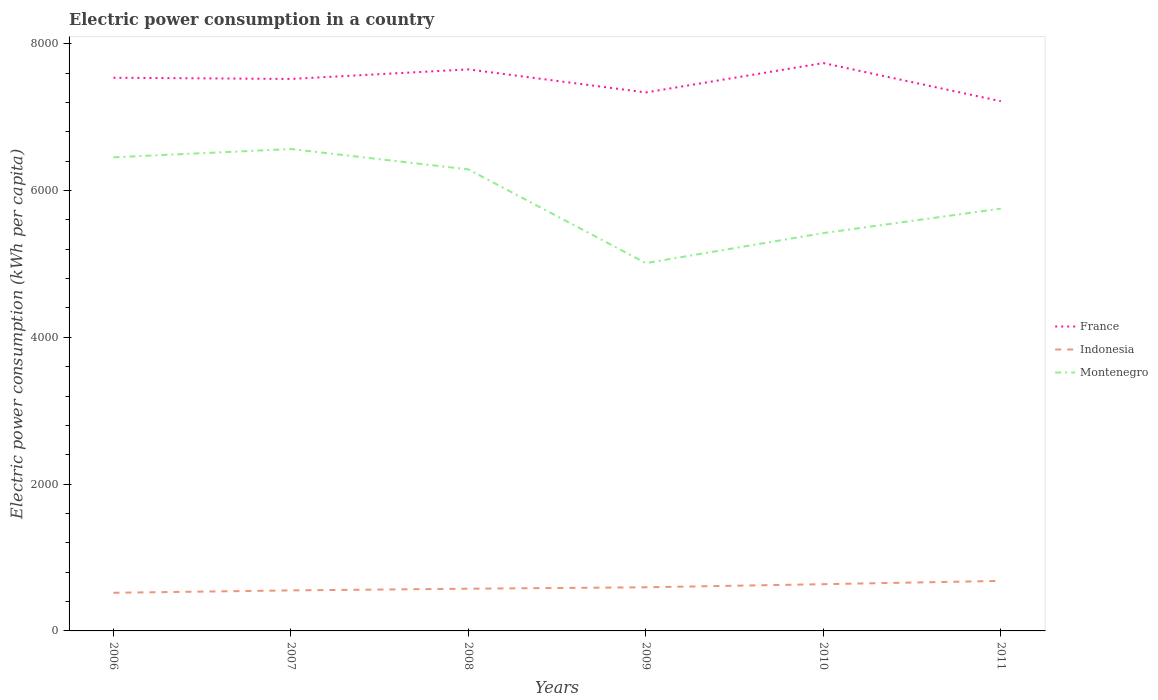How many different coloured lines are there?
Ensure brevity in your answer.  3. Does the line corresponding to Montenegro intersect with the line corresponding to Indonesia?
Your answer should be compact. No. Is the number of lines equal to the number of legend labels?
Give a very brief answer. Yes. Across all years, what is the maximum electric power consumption in in France?
Keep it short and to the point. 7216.07. What is the total electric power consumption in in Indonesia in the graph?
Your answer should be very brief. -19.44. What is the difference between the highest and the second highest electric power consumption in in Montenegro?
Your answer should be compact. 1554.08. What is the difference between the highest and the lowest electric power consumption in in France?
Your response must be concise. 4. Is the electric power consumption in in France strictly greater than the electric power consumption in in Indonesia over the years?
Your answer should be compact. No. How many years are there in the graph?
Offer a very short reply. 6. What is the difference between two consecutive major ticks on the Y-axis?
Give a very brief answer. 2000. Does the graph contain grids?
Make the answer very short. No. Where does the legend appear in the graph?
Your response must be concise. Center right. How many legend labels are there?
Provide a short and direct response. 3. How are the legend labels stacked?
Your response must be concise. Vertical. What is the title of the graph?
Your answer should be compact. Electric power consumption in a country. What is the label or title of the Y-axis?
Ensure brevity in your answer.  Electric power consumption (kWh per capita). What is the Electric power consumption (kWh per capita) of France in 2006?
Give a very brief answer. 7535.75. What is the Electric power consumption (kWh per capita) in Indonesia in 2006?
Offer a terse response. 519.51. What is the Electric power consumption (kWh per capita) of Montenegro in 2006?
Provide a short and direct response. 6451.77. What is the Electric power consumption (kWh per capita) in France in 2007?
Your answer should be very brief. 7519.31. What is the Electric power consumption (kWh per capita) in Indonesia in 2007?
Offer a terse response. 552.04. What is the Electric power consumption (kWh per capita) of Montenegro in 2007?
Make the answer very short. 6564.64. What is the Electric power consumption (kWh per capita) of France in 2008?
Ensure brevity in your answer.  7649.54. What is the Electric power consumption (kWh per capita) of Indonesia in 2008?
Give a very brief answer. 574.99. What is the Electric power consumption (kWh per capita) in Montenegro in 2008?
Offer a very short reply. 6287.19. What is the Electric power consumption (kWh per capita) in France in 2009?
Provide a short and direct response. 7335.52. What is the Electric power consumption (kWh per capita) in Indonesia in 2009?
Provide a succinct answer. 594.42. What is the Electric power consumption (kWh per capita) of Montenegro in 2009?
Keep it short and to the point. 5010.56. What is the Electric power consumption (kWh per capita) in France in 2010?
Your response must be concise. 7735.79. What is the Electric power consumption (kWh per capita) of Indonesia in 2010?
Your response must be concise. 636.69. What is the Electric power consumption (kWh per capita) of Montenegro in 2010?
Provide a succinct answer. 5419.52. What is the Electric power consumption (kWh per capita) of France in 2011?
Your answer should be very brief. 7216.07. What is the Electric power consumption (kWh per capita) in Indonesia in 2011?
Provide a succinct answer. 681.12. What is the Electric power consumption (kWh per capita) of Montenegro in 2011?
Ensure brevity in your answer.  5752.49. Across all years, what is the maximum Electric power consumption (kWh per capita) in France?
Your answer should be very brief. 7735.79. Across all years, what is the maximum Electric power consumption (kWh per capita) of Indonesia?
Give a very brief answer. 681.12. Across all years, what is the maximum Electric power consumption (kWh per capita) of Montenegro?
Ensure brevity in your answer.  6564.64. Across all years, what is the minimum Electric power consumption (kWh per capita) in France?
Offer a terse response. 7216.07. Across all years, what is the minimum Electric power consumption (kWh per capita) of Indonesia?
Give a very brief answer. 519.51. Across all years, what is the minimum Electric power consumption (kWh per capita) of Montenegro?
Provide a short and direct response. 5010.56. What is the total Electric power consumption (kWh per capita) in France in the graph?
Your response must be concise. 4.50e+04. What is the total Electric power consumption (kWh per capita) in Indonesia in the graph?
Your response must be concise. 3558.76. What is the total Electric power consumption (kWh per capita) of Montenegro in the graph?
Your response must be concise. 3.55e+04. What is the difference between the Electric power consumption (kWh per capita) in France in 2006 and that in 2007?
Make the answer very short. 16.44. What is the difference between the Electric power consumption (kWh per capita) in Indonesia in 2006 and that in 2007?
Offer a terse response. -32.53. What is the difference between the Electric power consumption (kWh per capita) of Montenegro in 2006 and that in 2007?
Your answer should be compact. -112.87. What is the difference between the Electric power consumption (kWh per capita) of France in 2006 and that in 2008?
Your answer should be very brief. -113.79. What is the difference between the Electric power consumption (kWh per capita) of Indonesia in 2006 and that in 2008?
Provide a short and direct response. -55.48. What is the difference between the Electric power consumption (kWh per capita) in Montenegro in 2006 and that in 2008?
Your answer should be compact. 164.58. What is the difference between the Electric power consumption (kWh per capita) in France in 2006 and that in 2009?
Your answer should be very brief. 200.23. What is the difference between the Electric power consumption (kWh per capita) of Indonesia in 2006 and that in 2009?
Provide a succinct answer. -74.92. What is the difference between the Electric power consumption (kWh per capita) of Montenegro in 2006 and that in 2009?
Provide a short and direct response. 1441.21. What is the difference between the Electric power consumption (kWh per capita) in France in 2006 and that in 2010?
Provide a succinct answer. -200.03. What is the difference between the Electric power consumption (kWh per capita) of Indonesia in 2006 and that in 2010?
Offer a very short reply. -117.18. What is the difference between the Electric power consumption (kWh per capita) in Montenegro in 2006 and that in 2010?
Your answer should be very brief. 1032.25. What is the difference between the Electric power consumption (kWh per capita) in France in 2006 and that in 2011?
Your response must be concise. 319.68. What is the difference between the Electric power consumption (kWh per capita) in Indonesia in 2006 and that in 2011?
Your answer should be very brief. -161.61. What is the difference between the Electric power consumption (kWh per capita) of Montenegro in 2006 and that in 2011?
Your answer should be compact. 699.28. What is the difference between the Electric power consumption (kWh per capita) of France in 2007 and that in 2008?
Provide a succinct answer. -130.23. What is the difference between the Electric power consumption (kWh per capita) of Indonesia in 2007 and that in 2008?
Provide a succinct answer. -22.95. What is the difference between the Electric power consumption (kWh per capita) of Montenegro in 2007 and that in 2008?
Ensure brevity in your answer.  277.46. What is the difference between the Electric power consumption (kWh per capita) in France in 2007 and that in 2009?
Keep it short and to the point. 183.79. What is the difference between the Electric power consumption (kWh per capita) in Indonesia in 2007 and that in 2009?
Provide a succinct answer. -42.39. What is the difference between the Electric power consumption (kWh per capita) of Montenegro in 2007 and that in 2009?
Offer a terse response. 1554.08. What is the difference between the Electric power consumption (kWh per capita) in France in 2007 and that in 2010?
Provide a short and direct response. -216.48. What is the difference between the Electric power consumption (kWh per capita) in Indonesia in 2007 and that in 2010?
Your answer should be compact. -84.65. What is the difference between the Electric power consumption (kWh per capita) of Montenegro in 2007 and that in 2010?
Offer a terse response. 1145.13. What is the difference between the Electric power consumption (kWh per capita) of France in 2007 and that in 2011?
Give a very brief answer. 303.24. What is the difference between the Electric power consumption (kWh per capita) in Indonesia in 2007 and that in 2011?
Your answer should be compact. -129.09. What is the difference between the Electric power consumption (kWh per capita) in Montenegro in 2007 and that in 2011?
Offer a very short reply. 812.15. What is the difference between the Electric power consumption (kWh per capita) in France in 2008 and that in 2009?
Make the answer very short. 314.02. What is the difference between the Electric power consumption (kWh per capita) in Indonesia in 2008 and that in 2009?
Make the answer very short. -19.44. What is the difference between the Electric power consumption (kWh per capita) of Montenegro in 2008 and that in 2009?
Give a very brief answer. 1276.63. What is the difference between the Electric power consumption (kWh per capita) of France in 2008 and that in 2010?
Offer a terse response. -86.25. What is the difference between the Electric power consumption (kWh per capita) of Indonesia in 2008 and that in 2010?
Give a very brief answer. -61.7. What is the difference between the Electric power consumption (kWh per capita) of Montenegro in 2008 and that in 2010?
Make the answer very short. 867.67. What is the difference between the Electric power consumption (kWh per capita) of France in 2008 and that in 2011?
Keep it short and to the point. 433.47. What is the difference between the Electric power consumption (kWh per capita) in Indonesia in 2008 and that in 2011?
Offer a very short reply. -106.14. What is the difference between the Electric power consumption (kWh per capita) in Montenegro in 2008 and that in 2011?
Your response must be concise. 534.7. What is the difference between the Electric power consumption (kWh per capita) of France in 2009 and that in 2010?
Keep it short and to the point. -400.26. What is the difference between the Electric power consumption (kWh per capita) in Indonesia in 2009 and that in 2010?
Your response must be concise. -42.27. What is the difference between the Electric power consumption (kWh per capita) in Montenegro in 2009 and that in 2010?
Your answer should be very brief. -408.95. What is the difference between the Electric power consumption (kWh per capita) of France in 2009 and that in 2011?
Make the answer very short. 119.45. What is the difference between the Electric power consumption (kWh per capita) in Indonesia in 2009 and that in 2011?
Keep it short and to the point. -86.7. What is the difference between the Electric power consumption (kWh per capita) in Montenegro in 2009 and that in 2011?
Keep it short and to the point. -741.93. What is the difference between the Electric power consumption (kWh per capita) of France in 2010 and that in 2011?
Your answer should be compact. 519.72. What is the difference between the Electric power consumption (kWh per capita) in Indonesia in 2010 and that in 2011?
Keep it short and to the point. -44.43. What is the difference between the Electric power consumption (kWh per capita) of Montenegro in 2010 and that in 2011?
Make the answer very short. -332.98. What is the difference between the Electric power consumption (kWh per capita) of France in 2006 and the Electric power consumption (kWh per capita) of Indonesia in 2007?
Provide a succinct answer. 6983.72. What is the difference between the Electric power consumption (kWh per capita) in France in 2006 and the Electric power consumption (kWh per capita) in Montenegro in 2007?
Give a very brief answer. 971.11. What is the difference between the Electric power consumption (kWh per capita) in Indonesia in 2006 and the Electric power consumption (kWh per capita) in Montenegro in 2007?
Keep it short and to the point. -6045.14. What is the difference between the Electric power consumption (kWh per capita) of France in 2006 and the Electric power consumption (kWh per capita) of Indonesia in 2008?
Offer a terse response. 6960.77. What is the difference between the Electric power consumption (kWh per capita) of France in 2006 and the Electric power consumption (kWh per capita) of Montenegro in 2008?
Your response must be concise. 1248.57. What is the difference between the Electric power consumption (kWh per capita) in Indonesia in 2006 and the Electric power consumption (kWh per capita) in Montenegro in 2008?
Your response must be concise. -5767.68. What is the difference between the Electric power consumption (kWh per capita) in France in 2006 and the Electric power consumption (kWh per capita) in Indonesia in 2009?
Your answer should be compact. 6941.33. What is the difference between the Electric power consumption (kWh per capita) in France in 2006 and the Electric power consumption (kWh per capita) in Montenegro in 2009?
Ensure brevity in your answer.  2525.19. What is the difference between the Electric power consumption (kWh per capita) in Indonesia in 2006 and the Electric power consumption (kWh per capita) in Montenegro in 2009?
Your answer should be compact. -4491.06. What is the difference between the Electric power consumption (kWh per capita) in France in 2006 and the Electric power consumption (kWh per capita) in Indonesia in 2010?
Provide a short and direct response. 6899.07. What is the difference between the Electric power consumption (kWh per capita) of France in 2006 and the Electric power consumption (kWh per capita) of Montenegro in 2010?
Provide a succinct answer. 2116.24. What is the difference between the Electric power consumption (kWh per capita) of Indonesia in 2006 and the Electric power consumption (kWh per capita) of Montenegro in 2010?
Make the answer very short. -4900.01. What is the difference between the Electric power consumption (kWh per capita) of France in 2006 and the Electric power consumption (kWh per capita) of Indonesia in 2011?
Make the answer very short. 6854.63. What is the difference between the Electric power consumption (kWh per capita) of France in 2006 and the Electric power consumption (kWh per capita) of Montenegro in 2011?
Provide a short and direct response. 1783.26. What is the difference between the Electric power consumption (kWh per capita) of Indonesia in 2006 and the Electric power consumption (kWh per capita) of Montenegro in 2011?
Give a very brief answer. -5232.99. What is the difference between the Electric power consumption (kWh per capita) in France in 2007 and the Electric power consumption (kWh per capita) in Indonesia in 2008?
Make the answer very short. 6944.33. What is the difference between the Electric power consumption (kWh per capita) of France in 2007 and the Electric power consumption (kWh per capita) of Montenegro in 2008?
Offer a very short reply. 1232.12. What is the difference between the Electric power consumption (kWh per capita) in Indonesia in 2007 and the Electric power consumption (kWh per capita) in Montenegro in 2008?
Keep it short and to the point. -5735.15. What is the difference between the Electric power consumption (kWh per capita) in France in 2007 and the Electric power consumption (kWh per capita) in Indonesia in 2009?
Give a very brief answer. 6924.89. What is the difference between the Electric power consumption (kWh per capita) of France in 2007 and the Electric power consumption (kWh per capita) of Montenegro in 2009?
Your response must be concise. 2508.75. What is the difference between the Electric power consumption (kWh per capita) of Indonesia in 2007 and the Electric power consumption (kWh per capita) of Montenegro in 2009?
Ensure brevity in your answer.  -4458.53. What is the difference between the Electric power consumption (kWh per capita) in France in 2007 and the Electric power consumption (kWh per capita) in Indonesia in 2010?
Keep it short and to the point. 6882.62. What is the difference between the Electric power consumption (kWh per capita) of France in 2007 and the Electric power consumption (kWh per capita) of Montenegro in 2010?
Your answer should be compact. 2099.8. What is the difference between the Electric power consumption (kWh per capita) of Indonesia in 2007 and the Electric power consumption (kWh per capita) of Montenegro in 2010?
Give a very brief answer. -4867.48. What is the difference between the Electric power consumption (kWh per capita) of France in 2007 and the Electric power consumption (kWh per capita) of Indonesia in 2011?
Ensure brevity in your answer.  6838.19. What is the difference between the Electric power consumption (kWh per capita) of France in 2007 and the Electric power consumption (kWh per capita) of Montenegro in 2011?
Provide a succinct answer. 1766.82. What is the difference between the Electric power consumption (kWh per capita) of Indonesia in 2007 and the Electric power consumption (kWh per capita) of Montenegro in 2011?
Make the answer very short. -5200.46. What is the difference between the Electric power consumption (kWh per capita) of France in 2008 and the Electric power consumption (kWh per capita) of Indonesia in 2009?
Offer a very short reply. 7055.12. What is the difference between the Electric power consumption (kWh per capita) in France in 2008 and the Electric power consumption (kWh per capita) in Montenegro in 2009?
Offer a terse response. 2638.98. What is the difference between the Electric power consumption (kWh per capita) in Indonesia in 2008 and the Electric power consumption (kWh per capita) in Montenegro in 2009?
Your response must be concise. -4435.58. What is the difference between the Electric power consumption (kWh per capita) in France in 2008 and the Electric power consumption (kWh per capita) in Indonesia in 2010?
Your answer should be compact. 7012.85. What is the difference between the Electric power consumption (kWh per capita) of France in 2008 and the Electric power consumption (kWh per capita) of Montenegro in 2010?
Your answer should be very brief. 2230.02. What is the difference between the Electric power consumption (kWh per capita) in Indonesia in 2008 and the Electric power consumption (kWh per capita) in Montenegro in 2010?
Your answer should be compact. -4844.53. What is the difference between the Electric power consumption (kWh per capita) of France in 2008 and the Electric power consumption (kWh per capita) of Indonesia in 2011?
Provide a short and direct response. 6968.42. What is the difference between the Electric power consumption (kWh per capita) of France in 2008 and the Electric power consumption (kWh per capita) of Montenegro in 2011?
Provide a short and direct response. 1897.05. What is the difference between the Electric power consumption (kWh per capita) of Indonesia in 2008 and the Electric power consumption (kWh per capita) of Montenegro in 2011?
Your answer should be very brief. -5177.51. What is the difference between the Electric power consumption (kWh per capita) of France in 2009 and the Electric power consumption (kWh per capita) of Indonesia in 2010?
Provide a short and direct response. 6698.84. What is the difference between the Electric power consumption (kWh per capita) in France in 2009 and the Electric power consumption (kWh per capita) in Montenegro in 2010?
Your answer should be compact. 1916.01. What is the difference between the Electric power consumption (kWh per capita) of Indonesia in 2009 and the Electric power consumption (kWh per capita) of Montenegro in 2010?
Keep it short and to the point. -4825.09. What is the difference between the Electric power consumption (kWh per capita) of France in 2009 and the Electric power consumption (kWh per capita) of Indonesia in 2011?
Make the answer very short. 6654.4. What is the difference between the Electric power consumption (kWh per capita) in France in 2009 and the Electric power consumption (kWh per capita) in Montenegro in 2011?
Your answer should be compact. 1583.03. What is the difference between the Electric power consumption (kWh per capita) in Indonesia in 2009 and the Electric power consumption (kWh per capita) in Montenegro in 2011?
Keep it short and to the point. -5158.07. What is the difference between the Electric power consumption (kWh per capita) of France in 2010 and the Electric power consumption (kWh per capita) of Indonesia in 2011?
Provide a short and direct response. 7054.67. What is the difference between the Electric power consumption (kWh per capita) in France in 2010 and the Electric power consumption (kWh per capita) in Montenegro in 2011?
Give a very brief answer. 1983.29. What is the difference between the Electric power consumption (kWh per capita) of Indonesia in 2010 and the Electric power consumption (kWh per capita) of Montenegro in 2011?
Your response must be concise. -5115.81. What is the average Electric power consumption (kWh per capita) of France per year?
Your answer should be very brief. 7498.66. What is the average Electric power consumption (kWh per capita) of Indonesia per year?
Offer a terse response. 593.13. What is the average Electric power consumption (kWh per capita) of Montenegro per year?
Provide a short and direct response. 5914.36. In the year 2006, what is the difference between the Electric power consumption (kWh per capita) of France and Electric power consumption (kWh per capita) of Indonesia?
Provide a short and direct response. 7016.25. In the year 2006, what is the difference between the Electric power consumption (kWh per capita) in France and Electric power consumption (kWh per capita) in Montenegro?
Your answer should be compact. 1083.98. In the year 2006, what is the difference between the Electric power consumption (kWh per capita) in Indonesia and Electric power consumption (kWh per capita) in Montenegro?
Ensure brevity in your answer.  -5932.26. In the year 2007, what is the difference between the Electric power consumption (kWh per capita) in France and Electric power consumption (kWh per capita) in Indonesia?
Your answer should be compact. 6967.28. In the year 2007, what is the difference between the Electric power consumption (kWh per capita) in France and Electric power consumption (kWh per capita) in Montenegro?
Make the answer very short. 954.67. In the year 2007, what is the difference between the Electric power consumption (kWh per capita) of Indonesia and Electric power consumption (kWh per capita) of Montenegro?
Offer a very short reply. -6012.61. In the year 2008, what is the difference between the Electric power consumption (kWh per capita) of France and Electric power consumption (kWh per capita) of Indonesia?
Provide a short and direct response. 7074.55. In the year 2008, what is the difference between the Electric power consumption (kWh per capita) of France and Electric power consumption (kWh per capita) of Montenegro?
Your answer should be compact. 1362.35. In the year 2008, what is the difference between the Electric power consumption (kWh per capita) in Indonesia and Electric power consumption (kWh per capita) in Montenegro?
Your answer should be very brief. -5712.2. In the year 2009, what is the difference between the Electric power consumption (kWh per capita) of France and Electric power consumption (kWh per capita) of Indonesia?
Give a very brief answer. 6741.1. In the year 2009, what is the difference between the Electric power consumption (kWh per capita) of France and Electric power consumption (kWh per capita) of Montenegro?
Offer a very short reply. 2324.96. In the year 2009, what is the difference between the Electric power consumption (kWh per capita) in Indonesia and Electric power consumption (kWh per capita) in Montenegro?
Offer a terse response. -4416.14. In the year 2010, what is the difference between the Electric power consumption (kWh per capita) of France and Electric power consumption (kWh per capita) of Indonesia?
Ensure brevity in your answer.  7099.1. In the year 2010, what is the difference between the Electric power consumption (kWh per capita) in France and Electric power consumption (kWh per capita) in Montenegro?
Provide a short and direct response. 2316.27. In the year 2010, what is the difference between the Electric power consumption (kWh per capita) of Indonesia and Electric power consumption (kWh per capita) of Montenegro?
Your answer should be very brief. -4782.83. In the year 2011, what is the difference between the Electric power consumption (kWh per capita) of France and Electric power consumption (kWh per capita) of Indonesia?
Offer a very short reply. 6534.95. In the year 2011, what is the difference between the Electric power consumption (kWh per capita) in France and Electric power consumption (kWh per capita) in Montenegro?
Keep it short and to the point. 1463.58. In the year 2011, what is the difference between the Electric power consumption (kWh per capita) of Indonesia and Electric power consumption (kWh per capita) of Montenegro?
Provide a succinct answer. -5071.37. What is the ratio of the Electric power consumption (kWh per capita) in France in 2006 to that in 2007?
Your answer should be compact. 1. What is the ratio of the Electric power consumption (kWh per capita) of Indonesia in 2006 to that in 2007?
Ensure brevity in your answer.  0.94. What is the ratio of the Electric power consumption (kWh per capita) of Montenegro in 2006 to that in 2007?
Provide a short and direct response. 0.98. What is the ratio of the Electric power consumption (kWh per capita) in France in 2006 to that in 2008?
Your answer should be compact. 0.99. What is the ratio of the Electric power consumption (kWh per capita) of Indonesia in 2006 to that in 2008?
Provide a succinct answer. 0.9. What is the ratio of the Electric power consumption (kWh per capita) in Montenegro in 2006 to that in 2008?
Give a very brief answer. 1.03. What is the ratio of the Electric power consumption (kWh per capita) in France in 2006 to that in 2009?
Your answer should be compact. 1.03. What is the ratio of the Electric power consumption (kWh per capita) of Indonesia in 2006 to that in 2009?
Provide a short and direct response. 0.87. What is the ratio of the Electric power consumption (kWh per capita) in Montenegro in 2006 to that in 2009?
Offer a terse response. 1.29. What is the ratio of the Electric power consumption (kWh per capita) in France in 2006 to that in 2010?
Ensure brevity in your answer.  0.97. What is the ratio of the Electric power consumption (kWh per capita) in Indonesia in 2006 to that in 2010?
Make the answer very short. 0.82. What is the ratio of the Electric power consumption (kWh per capita) in Montenegro in 2006 to that in 2010?
Give a very brief answer. 1.19. What is the ratio of the Electric power consumption (kWh per capita) in France in 2006 to that in 2011?
Provide a short and direct response. 1.04. What is the ratio of the Electric power consumption (kWh per capita) of Indonesia in 2006 to that in 2011?
Offer a terse response. 0.76. What is the ratio of the Electric power consumption (kWh per capita) of Montenegro in 2006 to that in 2011?
Your answer should be very brief. 1.12. What is the ratio of the Electric power consumption (kWh per capita) in Indonesia in 2007 to that in 2008?
Give a very brief answer. 0.96. What is the ratio of the Electric power consumption (kWh per capita) of Montenegro in 2007 to that in 2008?
Provide a succinct answer. 1.04. What is the ratio of the Electric power consumption (kWh per capita) in France in 2007 to that in 2009?
Keep it short and to the point. 1.03. What is the ratio of the Electric power consumption (kWh per capita) in Indonesia in 2007 to that in 2009?
Your response must be concise. 0.93. What is the ratio of the Electric power consumption (kWh per capita) of Montenegro in 2007 to that in 2009?
Make the answer very short. 1.31. What is the ratio of the Electric power consumption (kWh per capita) of Indonesia in 2007 to that in 2010?
Provide a short and direct response. 0.87. What is the ratio of the Electric power consumption (kWh per capita) in Montenegro in 2007 to that in 2010?
Your answer should be very brief. 1.21. What is the ratio of the Electric power consumption (kWh per capita) of France in 2007 to that in 2011?
Provide a short and direct response. 1.04. What is the ratio of the Electric power consumption (kWh per capita) in Indonesia in 2007 to that in 2011?
Give a very brief answer. 0.81. What is the ratio of the Electric power consumption (kWh per capita) in Montenegro in 2007 to that in 2011?
Keep it short and to the point. 1.14. What is the ratio of the Electric power consumption (kWh per capita) of France in 2008 to that in 2009?
Provide a short and direct response. 1.04. What is the ratio of the Electric power consumption (kWh per capita) of Indonesia in 2008 to that in 2009?
Provide a succinct answer. 0.97. What is the ratio of the Electric power consumption (kWh per capita) in Montenegro in 2008 to that in 2009?
Provide a short and direct response. 1.25. What is the ratio of the Electric power consumption (kWh per capita) of France in 2008 to that in 2010?
Make the answer very short. 0.99. What is the ratio of the Electric power consumption (kWh per capita) in Indonesia in 2008 to that in 2010?
Your response must be concise. 0.9. What is the ratio of the Electric power consumption (kWh per capita) in Montenegro in 2008 to that in 2010?
Offer a very short reply. 1.16. What is the ratio of the Electric power consumption (kWh per capita) in France in 2008 to that in 2011?
Give a very brief answer. 1.06. What is the ratio of the Electric power consumption (kWh per capita) of Indonesia in 2008 to that in 2011?
Your answer should be compact. 0.84. What is the ratio of the Electric power consumption (kWh per capita) in Montenegro in 2008 to that in 2011?
Your response must be concise. 1.09. What is the ratio of the Electric power consumption (kWh per capita) in France in 2009 to that in 2010?
Ensure brevity in your answer.  0.95. What is the ratio of the Electric power consumption (kWh per capita) of Indonesia in 2009 to that in 2010?
Your answer should be compact. 0.93. What is the ratio of the Electric power consumption (kWh per capita) of Montenegro in 2009 to that in 2010?
Your answer should be compact. 0.92. What is the ratio of the Electric power consumption (kWh per capita) of France in 2009 to that in 2011?
Your response must be concise. 1.02. What is the ratio of the Electric power consumption (kWh per capita) in Indonesia in 2009 to that in 2011?
Provide a short and direct response. 0.87. What is the ratio of the Electric power consumption (kWh per capita) in Montenegro in 2009 to that in 2011?
Provide a short and direct response. 0.87. What is the ratio of the Electric power consumption (kWh per capita) of France in 2010 to that in 2011?
Keep it short and to the point. 1.07. What is the ratio of the Electric power consumption (kWh per capita) in Indonesia in 2010 to that in 2011?
Make the answer very short. 0.93. What is the ratio of the Electric power consumption (kWh per capita) of Montenegro in 2010 to that in 2011?
Offer a very short reply. 0.94. What is the difference between the highest and the second highest Electric power consumption (kWh per capita) in France?
Offer a terse response. 86.25. What is the difference between the highest and the second highest Electric power consumption (kWh per capita) in Indonesia?
Make the answer very short. 44.43. What is the difference between the highest and the second highest Electric power consumption (kWh per capita) in Montenegro?
Keep it short and to the point. 112.87. What is the difference between the highest and the lowest Electric power consumption (kWh per capita) in France?
Ensure brevity in your answer.  519.72. What is the difference between the highest and the lowest Electric power consumption (kWh per capita) of Indonesia?
Make the answer very short. 161.61. What is the difference between the highest and the lowest Electric power consumption (kWh per capita) of Montenegro?
Keep it short and to the point. 1554.08. 